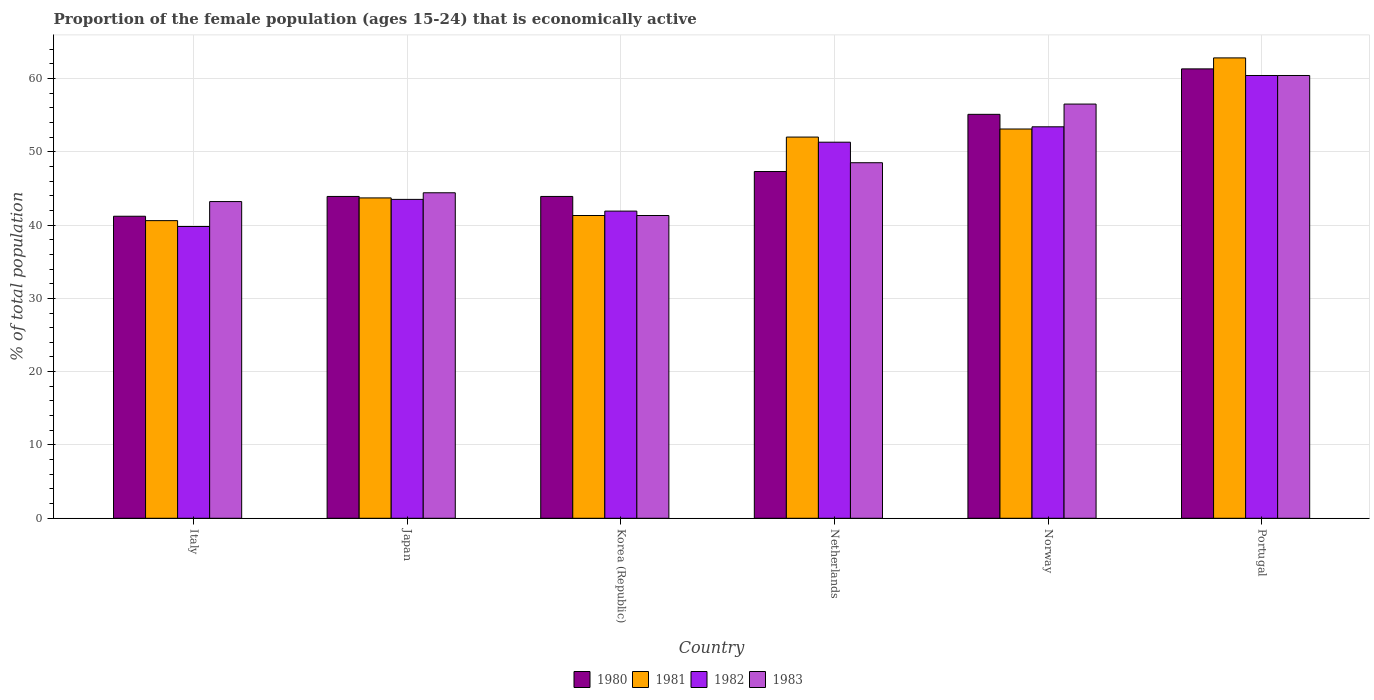How many different coloured bars are there?
Make the answer very short. 4. How many groups of bars are there?
Make the answer very short. 6. Are the number of bars per tick equal to the number of legend labels?
Give a very brief answer. Yes. Are the number of bars on each tick of the X-axis equal?
Your answer should be very brief. Yes. How many bars are there on the 5th tick from the left?
Ensure brevity in your answer.  4. How many bars are there on the 6th tick from the right?
Your response must be concise. 4. In how many cases, is the number of bars for a given country not equal to the number of legend labels?
Make the answer very short. 0. What is the proportion of the female population that is economically active in 1981 in Italy?
Give a very brief answer. 40.6. Across all countries, what is the maximum proportion of the female population that is economically active in 1981?
Ensure brevity in your answer.  62.8. Across all countries, what is the minimum proportion of the female population that is economically active in 1983?
Offer a terse response. 41.3. What is the total proportion of the female population that is economically active in 1983 in the graph?
Provide a succinct answer. 294.3. What is the difference between the proportion of the female population that is economically active in 1983 in Netherlands and that in Norway?
Ensure brevity in your answer.  -8. What is the difference between the proportion of the female population that is economically active in 1983 in Japan and the proportion of the female population that is economically active in 1981 in Norway?
Provide a short and direct response. -8.7. What is the average proportion of the female population that is economically active in 1982 per country?
Your answer should be compact. 48.38. What is the difference between the proportion of the female population that is economically active of/in 1980 and proportion of the female population that is economically active of/in 1983 in Italy?
Your answer should be compact. -2. What is the ratio of the proportion of the female population that is economically active in 1981 in Korea (Republic) to that in Norway?
Offer a terse response. 0.78. Is the difference between the proportion of the female population that is economically active in 1980 in Italy and Korea (Republic) greater than the difference between the proportion of the female population that is economically active in 1983 in Italy and Korea (Republic)?
Your answer should be very brief. No. What is the difference between the highest and the lowest proportion of the female population that is economically active in 1980?
Keep it short and to the point. 20.1. What does the 2nd bar from the left in Korea (Republic) represents?
Your answer should be very brief. 1981. Is it the case that in every country, the sum of the proportion of the female population that is economically active in 1983 and proportion of the female population that is economically active in 1980 is greater than the proportion of the female population that is economically active in 1981?
Give a very brief answer. Yes. How many bars are there?
Your answer should be compact. 24. How many countries are there in the graph?
Ensure brevity in your answer.  6. Are the values on the major ticks of Y-axis written in scientific E-notation?
Your answer should be compact. No. Where does the legend appear in the graph?
Make the answer very short. Bottom center. How many legend labels are there?
Your response must be concise. 4. What is the title of the graph?
Provide a succinct answer. Proportion of the female population (ages 15-24) that is economically active. What is the label or title of the Y-axis?
Keep it short and to the point. % of total population. What is the % of total population in 1980 in Italy?
Ensure brevity in your answer.  41.2. What is the % of total population of 1981 in Italy?
Provide a succinct answer. 40.6. What is the % of total population of 1982 in Italy?
Give a very brief answer. 39.8. What is the % of total population of 1983 in Italy?
Your answer should be very brief. 43.2. What is the % of total population of 1980 in Japan?
Offer a very short reply. 43.9. What is the % of total population in 1981 in Japan?
Offer a terse response. 43.7. What is the % of total population of 1982 in Japan?
Provide a succinct answer. 43.5. What is the % of total population of 1983 in Japan?
Your answer should be very brief. 44.4. What is the % of total population in 1980 in Korea (Republic)?
Your answer should be compact. 43.9. What is the % of total population of 1981 in Korea (Republic)?
Your response must be concise. 41.3. What is the % of total population of 1982 in Korea (Republic)?
Ensure brevity in your answer.  41.9. What is the % of total population of 1983 in Korea (Republic)?
Your answer should be compact. 41.3. What is the % of total population of 1980 in Netherlands?
Provide a succinct answer. 47.3. What is the % of total population of 1982 in Netherlands?
Make the answer very short. 51.3. What is the % of total population of 1983 in Netherlands?
Provide a short and direct response. 48.5. What is the % of total population in 1980 in Norway?
Ensure brevity in your answer.  55.1. What is the % of total population in 1981 in Norway?
Provide a short and direct response. 53.1. What is the % of total population in 1982 in Norway?
Keep it short and to the point. 53.4. What is the % of total population of 1983 in Norway?
Provide a succinct answer. 56.5. What is the % of total population in 1980 in Portugal?
Offer a very short reply. 61.3. What is the % of total population of 1981 in Portugal?
Your response must be concise. 62.8. What is the % of total population of 1982 in Portugal?
Your answer should be compact. 60.4. What is the % of total population of 1983 in Portugal?
Offer a very short reply. 60.4. Across all countries, what is the maximum % of total population of 1980?
Keep it short and to the point. 61.3. Across all countries, what is the maximum % of total population in 1981?
Provide a short and direct response. 62.8. Across all countries, what is the maximum % of total population of 1982?
Make the answer very short. 60.4. Across all countries, what is the maximum % of total population of 1983?
Provide a succinct answer. 60.4. Across all countries, what is the minimum % of total population of 1980?
Provide a succinct answer. 41.2. Across all countries, what is the minimum % of total population in 1981?
Offer a very short reply. 40.6. Across all countries, what is the minimum % of total population in 1982?
Make the answer very short. 39.8. Across all countries, what is the minimum % of total population in 1983?
Your response must be concise. 41.3. What is the total % of total population in 1980 in the graph?
Make the answer very short. 292.7. What is the total % of total population of 1981 in the graph?
Your answer should be compact. 293.5. What is the total % of total population in 1982 in the graph?
Your answer should be compact. 290.3. What is the total % of total population of 1983 in the graph?
Give a very brief answer. 294.3. What is the difference between the % of total population in 1980 in Italy and that in Japan?
Give a very brief answer. -2.7. What is the difference between the % of total population of 1980 in Italy and that in Korea (Republic)?
Provide a short and direct response. -2.7. What is the difference between the % of total population in 1981 in Italy and that in Korea (Republic)?
Keep it short and to the point. -0.7. What is the difference between the % of total population in 1980 in Italy and that in Netherlands?
Give a very brief answer. -6.1. What is the difference between the % of total population of 1981 in Italy and that in Netherlands?
Your answer should be very brief. -11.4. What is the difference between the % of total population of 1982 in Italy and that in Netherlands?
Ensure brevity in your answer.  -11.5. What is the difference between the % of total population of 1983 in Italy and that in Netherlands?
Ensure brevity in your answer.  -5.3. What is the difference between the % of total population of 1982 in Italy and that in Norway?
Provide a short and direct response. -13.6. What is the difference between the % of total population of 1980 in Italy and that in Portugal?
Your answer should be very brief. -20.1. What is the difference between the % of total population of 1981 in Italy and that in Portugal?
Your answer should be compact. -22.2. What is the difference between the % of total population in 1982 in Italy and that in Portugal?
Provide a succinct answer. -20.6. What is the difference between the % of total population in 1983 in Italy and that in Portugal?
Keep it short and to the point. -17.2. What is the difference between the % of total population in 1982 in Japan and that in Korea (Republic)?
Your answer should be very brief. 1.6. What is the difference between the % of total population of 1980 in Japan and that in Netherlands?
Ensure brevity in your answer.  -3.4. What is the difference between the % of total population of 1982 in Japan and that in Netherlands?
Offer a terse response. -7.8. What is the difference between the % of total population of 1980 in Japan and that in Norway?
Offer a very short reply. -11.2. What is the difference between the % of total population of 1981 in Japan and that in Norway?
Offer a very short reply. -9.4. What is the difference between the % of total population of 1980 in Japan and that in Portugal?
Your response must be concise. -17.4. What is the difference between the % of total population in 1981 in Japan and that in Portugal?
Provide a short and direct response. -19.1. What is the difference between the % of total population in 1982 in Japan and that in Portugal?
Ensure brevity in your answer.  -16.9. What is the difference between the % of total population of 1983 in Japan and that in Portugal?
Provide a succinct answer. -16. What is the difference between the % of total population in 1980 in Korea (Republic) and that in Netherlands?
Make the answer very short. -3.4. What is the difference between the % of total population in 1981 in Korea (Republic) and that in Netherlands?
Offer a very short reply. -10.7. What is the difference between the % of total population in 1982 in Korea (Republic) and that in Netherlands?
Offer a very short reply. -9.4. What is the difference between the % of total population of 1983 in Korea (Republic) and that in Netherlands?
Provide a succinct answer. -7.2. What is the difference between the % of total population in 1980 in Korea (Republic) and that in Norway?
Offer a very short reply. -11.2. What is the difference between the % of total population of 1981 in Korea (Republic) and that in Norway?
Give a very brief answer. -11.8. What is the difference between the % of total population of 1983 in Korea (Republic) and that in Norway?
Ensure brevity in your answer.  -15.2. What is the difference between the % of total population in 1980 in Korea (Republic) and that in Portugal?
Your answer should be compact. -17.4. What is the difference between the % of total population of 1981 in Korea (Republic) and that in Portugal?
Your answer should be compact. -21.5. What is the difference between the % of total population in 1982 in Korea (Republic) and that in Portugal?
Give a very brief answer. -18.5. What is the difference between the % of total population of 1983 in Korea (Republic) and that in Portugal?
Offer a very short reply. -19.1. What is the difference between the % of total population of 1980 in Netherlands and that in Portugal?
Your answer should be compact. -14. What is the difference between the % of total population in 1982 in Netherlands and that in Portugal?
Your response must be concise. -9.1. What is the difference between the % of total population of 1983 in Netherlands and that in Portugal?
Provide a short and direct response. -11.9. What is the difference between the % of total population in 1981 in Norway and that in Portugal?
Offer a very short reply. -9.7. What is the difference between the % of total population of 1983 in Norway and that in Portugal?
Your response must be concise. -3.9. What is the difference between the % of total population of 1980 in Italy and the % of total population of 1982 in Japan?
Ensure brevity in your answer.  -2.3. What is the difference between the % of total population in 1981 in Italy and the % of total population in 1982 in Japan?
Give a very brief answer. -2.9. What is the difference between the % of total population in 1981 in Italy and the % of total population in 1983 in Japan?
Offer a very short reply. -3.8. What is the difference between the % of total population in 1982 in Italy and the % of total population in 1983 in Japan?
Offer a terse response. -4.6. What is the difference between the % of total population of 1980 in Italy and the % of total population of 1981 in Korea (Republic)?
Your answer should be very brief. -0.1. What is the difference between the % of total population in 1980 in Italy and the % of total population in 1982 in Korea (Republic)?
Make the answer very short. -0.7. What is the difference between the % of total population in 1980 in Italy and the % of total population in 1983 in Korea (Republic)?
Ensure brevity in your answer.  -0.1. What is the difference between the % of total population in 1981 in Italy and the % of total population in 1982 in Korea (Republic)?
Make the answer very short. -1.3. What is the difference between the % of total population of 1981 in Italy and the % of total population of 1983 in Korea (Republic)?
Keep it short and to the point. -0.7. What is the difference between the % of total population of 1982 in Italy and the % of total population of 1983 in Korea (Republic)?
Ensure brevity in your answer.  -1.5. What is the difference between the % of total population of 1980 in Italy and the % of total population of 1982 in Netherlands?
Make the answer very short. -10.1. What is the difference between the % of total population in 1981 in Italy and the % of total population in 1983 in Netherlands?
Make the answer very short. -7.9. What is the difference between the % of total population of 1980 in Italy and the % of total population of 1981 in Norway?
Ensure brevity in your answer.  -11.9. What is the difference between the % of total population in 1980 in Italy and the % of total population in 1983 in Norway?
Keep it short and to the point. -15.3. What is the difference between the % of total population of 1981 in Italy and the % of total population of 1982 in Norway?
Keep it short and to the point. -12.8. What is the difference between the % of total population in 1981 in Italy and the % of total population in 1983 in Norway?
Give a very brief answer. -15.9. What is the difference between the % of total population in 1982 in Italy and the % of total population in 1983 in Norway?
Ensure brevity in your answer.  -16.7. What is the difference between the % of total population in 1980 in Italy and the % of total population in 1981 in Portugal?
Your response must be concise. -21.6. What is the difference between the % of total population in 1980 in Italy and the % of total population in 1982 in Portugal?
Keep it short and to the point. -19.2. What is the difference between the % of total population of 1980 in Italy and the % of total population of 1983 in Portugal?
Offer a very short reply. -19.2. What is the difference between the % of total population of 1981 in Italy and the % of total population of 1982 in Portugal?
Keep it short and to the point. -19.8. What is the difference between the % of total population in 1981 in Italy and the % of total population in 1983 in Portugal?
Ensure brevity in your answer.  -19.8. What is the difference between the % of total population of 1982 in Italy and the % of total population of 1983 in Portugal?
Keep it short and to the point. -20.6. What is the difference between the % of total population of 1980 in Japan and the % of total population of 1983 in Korea (Republic)?
Your answer should be very brief. 2.6. What is the difference between the % of total population in 1981 in Japan and the % of total population in 1982 in Korea (Republic)?
Give a very brief answer. 1.8. What is the difference between the % of total population in 1982 in Japan and the % of total population in 1983 in Korea (Republic)?
Your response must be concise. 2.2. What is the difference between the % of total population in 1980 in Japan and the % of total population in 1982 in Netherlands?
Provide a short and direct response. -7.4. What is the difference between the % of total population in 1980 in Japan and the % of total population in 1983 in Netherlands?
Offer a terse response. -4.6. What is the difference between the % of total population of 1981 in Japan and the % of total population of 1983 in Netherlands?
Offer a terse response. -4.8. What is the difference between the % of total population of 1980 in Japan and the % of total population of 1981 in Norway?
Keep it short and to the point. -9.2. What is the difference between the % of total population in 1980 in Japan and the % of total population in 1983 in Norway?
Give a very brief answer. -12.6. What is the difference between the % of total population of 1981 in Japan and the % of total population of 1982 in Norway?
Make the answer very short. -9.7. What is the difference between the % of total population of 1981 in Japan and the % of total population of 1983 in Norway?
Provide a short and direct response. -12.8. What is the difference between the % of total population in 1980 in Japan and the % of total population in 1981 in Portugal?
Your answer should be very brief. -18.9. What is the difference between the % of total population in 1980 in Japan and the % of total population in 1982 in Portugal?
Your answer should be very brief. -16.5. What is the difference between the % of total population in 1980 in Japan and the % of total population in 1983 in Portugal?
Your answer should be compact. -16.5. What is the difference between the % of total population in 1981 in Japan and the % of total population in 1982 in Portugal?
Your response must be concise. -16.7. What is the difference between the % of total population of 1981 in Japan and the % of total population of 1983 in Portugal?
Offer a terse response. -16.7. What is the difference between the % of total population in 1982 in Japan and the % of total population in 1983 in Portugal?
Your response must be concise. -16.9. What is the difference between the % of total population of 1980 in Korea (Republic) and the % of total population of 1981 in Netherlands?
Make the answer very short. -8.1. What is the difference between the % of total population in 1980 in Korea (Republic) and the % of total population in 1983 in Netherlands?
Provide a short and direct response. -4.6. What is the difference between the % of total population of 1981 in Korea (Republic) and the % of total population of 1982 in Netherlands?
Give a very brief answer. -10. What is the difference between the % of total population in 1982 in Korea (Republic) and the % of total population in 1983 in Netherlands?
Provide a succinct answer. -6.6. What is the difference between the % of total population in 1980 in Korea (Republic) and the % of total population in 1982 in Norway?
Your answer should be compact. -9.5. What is the difference between the % of total population in 1981 in Korea (Republic) and the % of total population in 1983 in Norway?
Ensure brevity in your answer.  -15.2. What is the difference between the % of total population of 1982 in Korea (Republic) and the % of total population of 1983 in Norway?
Ensure brevity in your answer.  -14.6. What is the difference between the % of total population of 1980 in Korea (Republic) and the % of total population of 1981 in Portugal?
Provide a short and direct response. -18.9. What is the difference between the % of total population of 1980 in Korea (Republic) and the % of total population of 1982 in Portugal?
Your answer should be compact. -16.5. What is the difference between the % of total population of 1980 in Korea (Republic) and the % of total population of 1983 in Portugal?
Your answer should be very brief. -16.5. What is the difference between the % of total population of 1981 in Korea (Republic) and the % of total population of 1982 in Portugal?
Provide a succinct answer. -19.1. What is the difference between the % of total population in 1981 in Korea (Republic) and the % of total population in 1983 in Portugal?
Ensure brevity in your answer.  -19.1. What is the difference between the % of total population of 1982 in Korea (Republic) and the % of total population of 1983 in Portugal?
Provide a succinct answer. -18.5. What is the difference between the % of total population in 1980 in Netherlands and the % of total population in 1981 in Norway?
Your answer should be very brief. -5.8. What is the difference between the % of total population of 1981 in Netherlands and the % of total population of 1982 in Norway?
Your answer should be very brief. -1.4. What is the difference between the % of total population in 1982 in Netherlands and the % of total population in 1983 in Norway?
Keep it short and to the point. -5.2. What is the difference between the % of total population of 1980 in Netherlands and the % of total population of 1981 in Portugal?
Provide a succinct answer. -15.5. What is the difference between the % of total population in 1981 in Netherlands and the % of total population in 1983 in Portugal?
Ensure brevity in your answer.  -8.4. What is the difference between the % of total population in 1980 in Norway and the % of total population in 1982 in Portugal?
Make the answer very short. -5.3. What is the difference between the % of total population of 1981 in Norway and the % of total population of 1982 in Portugal?
Provide a succinct answer. -7.3. What is the difference between the % of total population of 1982 in Norway and the % of total population of 1983 in Portugal?
Your answer should be very brief. -7. What is the average % of total population of 1980 per country?
Your response must be concise. 48.78. What is the average % of total population of 1981 per country?
Offer a very short reply. 48.92. What is the average % of total population in 1982 per country?
Your answer should be compact. 48.38. What is the average % of total population in 1983 per country?
Your answer should be very brief. 49.05. What is the difference between the % of total population in 1980 and % of total population in 1981 in Italy?
Your response must be concise. 0.6. What is the difference between the % of total population in 1980 and % of total population in 1982 in Italy?
Your answer should be very brief. 1.4. What is the difference between the % of total population of 1981 and % of total population of 1983 in Italy?
Offer a terse response. -2.6. What is the difference between the % of total population of 1982 and % of total population of 1983 in Italy?
Make the answer very short. -3.4. What is the difference between the % of total population in 1982 and % of total population in 1983 in Japan?
Ensure brevity in your answer.  -0.9. What is the difference between the % of total population in 1980 and % of total population in 1981 in Korea (Republic)?
Ensure brevity in your answer.  2.6. What is the difference between the % of total population of 1980 and % of total population of 1983 in Korea (Republic)?
Offer a terse response. 2.6. What is the difference between the % of total population in 1981 and % of total population in 1982 in Korea (Republic)?
Make the answer very short. -0.6. What is the difference between the % of total population in 1981 and % of total population in 1983 in Korea (Republic)?
Give a very brief answer. 0. What is the difference between the % of total population in 1982 and % of total population in 1983 in Korea (Republic)?
Your answer should be compact. 0.6. What is the difference between the % of total population in 1980 and % of total population in 1981 in Netherlands?
Your response must be concise. -4.7. What is the difference between the % of total population in 1981 and % of total population in 1982 in Netherlands?
Your answer should be compact. 0.7. What is the difference between the % of total population of 1981 and % of total population of 1983 in Netherlands?
Make the answer very short. 3.5. What is the difference between the % of total population in 1982 and % of total population in 1983 in Netherlands?
Your answer should be compact. 2.8. What is the difference between the % of total population in 1980 and % of total population in 1982 in Norway?
Offer a very short reply. 1.7. What is the difference between the % of total population in 1980 and % of total population in 1983 in Norway?
Your response must be concise. -1.4. What is the difference between the % of total population of 1981 and % of total population of 1982 in Norway?
Offer a very short reply. -0.3. What is the difference between the % of total population in 1981 and % of total population in 1983 in Norway?
Your answer should be very brief. -3.4. What is the difference between the % of total population in 1982 and % of total population in 1983 in Norway?
Offer a very short reply. -3.1. What is the difference between the % of total population of 1981 and % of total population of 1982 in Portugal?
Give a very brief answer. 2.4. What is the difference between the % of total population of 1981 and % of total population of 1983 in Portugal?
Your answer should be compact. 2.4. What is the ratio of the % of total population of 1980 in Italy to that in Japan?
Keep it short and to the point. 0.94. What is the ratio of the % of total population of 1981 in Italy to that in Japan?
Make the answer very short. 0.93. What is the ratio of the % of total population in 1982 in Italy to that in Japan?
Make the answer very short. 0.91. What is the ratio of the % of total population of 1980 in Italy to that in Korea (Republic)?
Your answer should be very brief. 0.94. What is the ratio of the % of total population of 1981 in Italy to that in Korea (Republic)?
Offer a terse response. 0.98. What is the ratio of the % of total population in 1982 in Italy to that in Korea (Republic)?
Your answer should be very brief. 0.95. What is the ratio of the % of total population of 1983 in Italy to that in Korea (Republic)?
Ensure brevity in your answer.  1.05. What is the ratio of the % of total population of 1980 in Italy to that in Netherlands?
Keep it short and to the point. 0.87. What is the ratio of the % of total population in 1981 in Italy to that in Netherlands?
Provide a succinct answer. 0.78. What is the ratio of the % of total population in 1982 in Italy to that in Netherlands?
Provide a succinct answer. 0.78. What is the ratio of the % of total population of 1983 in Italy to that in Netherlands?
Offer a terse response. 0.89. What is the ratio of the % of total population in 1980 in Italy to that in Norway?
Your response must be concise. 0.75. What is the ratio of the % of total population in 1981 in Italy to that in Norway?
Give a very brief answer. 0.76. What is the ratio of the % of total population in 1982 in Italy to that in Norway?
Make the answer very short. 0.75. What is the ratio of the % of total population in 1983 in Italy to that in Norway?
Keep it short and to the point. 0.76. What is the ratio of the % of total population of 1980 in Italy to that in Portugal?
Make the answer very short. 0.67. What is the ratio of the % of total population in 1981 in Italy to that in Portugal?
Your answer should be very brief. 0.65. What is the ratio of the % of total population in 1982 in Italy to that in Portugal?
Offer a terse response. 0.66. What is the ratio of the % of total population in 1983 in Italy to that in Portugal?
Offer a terse response. 0.72. What is the ratio of the % of total population of 1981 in Japan to that in Korea (Republic)?
Give a very brief answer. 1.06. What is the ratio of the % of total population of 1982 in Japan to that in Korea (Republic)?
Make the answer very short. 1.04. What is the ratio of the % of total population in 1983 in Japan to that in Korea (Republic)?
Keep it short and to the point. 1.08. What is the ratio of the % of total population in 1980 in Japan to that in Netherlands?
Your answer should be very brief. 0.93. What is the ratio of the % of total population of 1981 in Japan to that in Netherlands?
Offer a terse response. 0.84. What is the ratio of the % of total population of 1982 in Japan to that in Netherlands?
Offer a terse response. 0.85. What is the ratio of the % of total population of 1983 in Japan to that in Netherlands?
Give a very brief answer. 0.92. What is the ratio of the % of total population in 1980 in Japan to that in Norway?
Offer a terse response. 0.8. What is the ratio of the % of total population in 1981 in Japan to that in Norway?
Your answer should be compact. 0.82. What is the ratio of the % of total population in 1982 in Japan to that in Norway?
Make the answer very short. 0.81. What is the ratio of the % of total population in 1983 in Japan to that in Norway?
Provide a short and direct response. 0.79. What is the ratio of the % of total population in 1980 in Japan to that in Portugal?
Your answer should be very brief. 0.72. What is the ratio of the % of total population in 1981 in Japan to that in Portugal?
Your answer should be very brief. 0.7. What is the ratio of the % of total population of 1982 in Japan to that in Portugal?
Offer a terse response. 0.72. What is the ratio of the % of total population in 1983 in Japan to that in Portugal?
Your answer should be compact. 0.74. What is the ratio of the % of total population in 1980 in Korea (Republic) to that in Netherlands?
Give a very brief answer. 0.93. What is the ratio of the % of total population of 1981 in Korea (Republic) to that in Netherlands?
Offer a terse response. 0.79. What is the ratio of the % of total population of 1982 in Korea (Republic) to that in Netherlands?
Offer a terse response. 0.82. What is the ratio of the % of total population in 1983 in Korea (Republic) to that in Netherlands?
Offer a terse response. 0.85. What is the ratio of the % of total population in 1980 in Korea (Republic) to that in Norway?
Ensure brevity in your answer.  0.8. What is the ratio of the % of total population in 1981 in Korea (Republic) to that in Norway?
Keep it short and to the point. 0.78. What is the ratio of the % of total population of 1982 in Korea (Republic) to that in Norway?
Offer a terse response. 0.78. What is the ratio of the % of total population in 1983 in Korea (Republic) to that in Norway?
Ensure brevity in your answer.  0.73. What is the ratio of the % of total population of 1980 in Korea (Republic) to that in Portugal?
Your answer should be very brief. 0.72. What is the ratio of the % of total population in 1981 in Korea (Republic) to that in Portugal?
Your answer should be compact. 0.66. What is the ratio of the % of total population in 1982 in Korea (Republic) to that in Portugal?
Your response must be concise. 0.69. What is the ratio of the % of total population of 1983 in Korea (Republic) to that in Portugal?
Ensure brevity in your answer.  0.68. What is the ratio of the % of total population of 1980 in Netherlands to that in Norway?
Your response must be concise. 0.86. What is the ratio of the % of total population of 1981 in Netherlands to that in Norway?
Offer a terse response. 0.98. What is the ratio of the % of total population of 1982 in Netherlands to that in Norway?
Offer a very short reply. 0.96. What is the ratio of the % of total population in 1983 in Netherlands to that in Norway?
Your answer should be compact. 0.86. What is the ratio of the % of total population in 1980 in Netherlands to that in Portugal?
Provide a short and direct response. 0.77. What is the ratio of the % of total population in 1981 in Netherlands to that in Portugal?
Offer a terse response. 0.83. What is the ratio of the % of total population of 1982 in Netherlands to that in Portugal?
Ensure brevity in your answer.  0.85. What is the ratio of the % of total population of 1983 in Netherlands to that in Portugal?
Make the answer very short. 0.8. What is the ratio of the % of total population of 1980 in Norway to that in Portugal?
Your answer should be very brief. 0.9. What is the ratio of the % of total population in 1981 in Norway to that in Portugal?
Ensure brevity in your answer.  0.85. What is the ratio of the % of total population of 1982 in Norway to that in Portugal?
Your answer should be compact. 0.88. What is the ratio of the % of total population of 1983 in Norway to that in Portugal?
Your answer should be compact. 0.94. What is the difference between the highest and the second highest % of total population in 1981?
Offer a terse response. 9.7. What is the difference between the highest and the second highest % of total population of 1982?
Provide a short and direct response. 7. What is the difference between the highest and the second highest % of total population of 1983?
Your response must be concise. 3.9. What is the difference between the highest and the lowest % of total population in 1980?
Make the answer very short. 20.1. What is the difference between the highest and the lowest % of total population in 1982?
Offer a very short reply. 20.6. What is the difference between the highest and the lowest % of total population in 1983?
Ensure brevity in your answer.  19.1. 